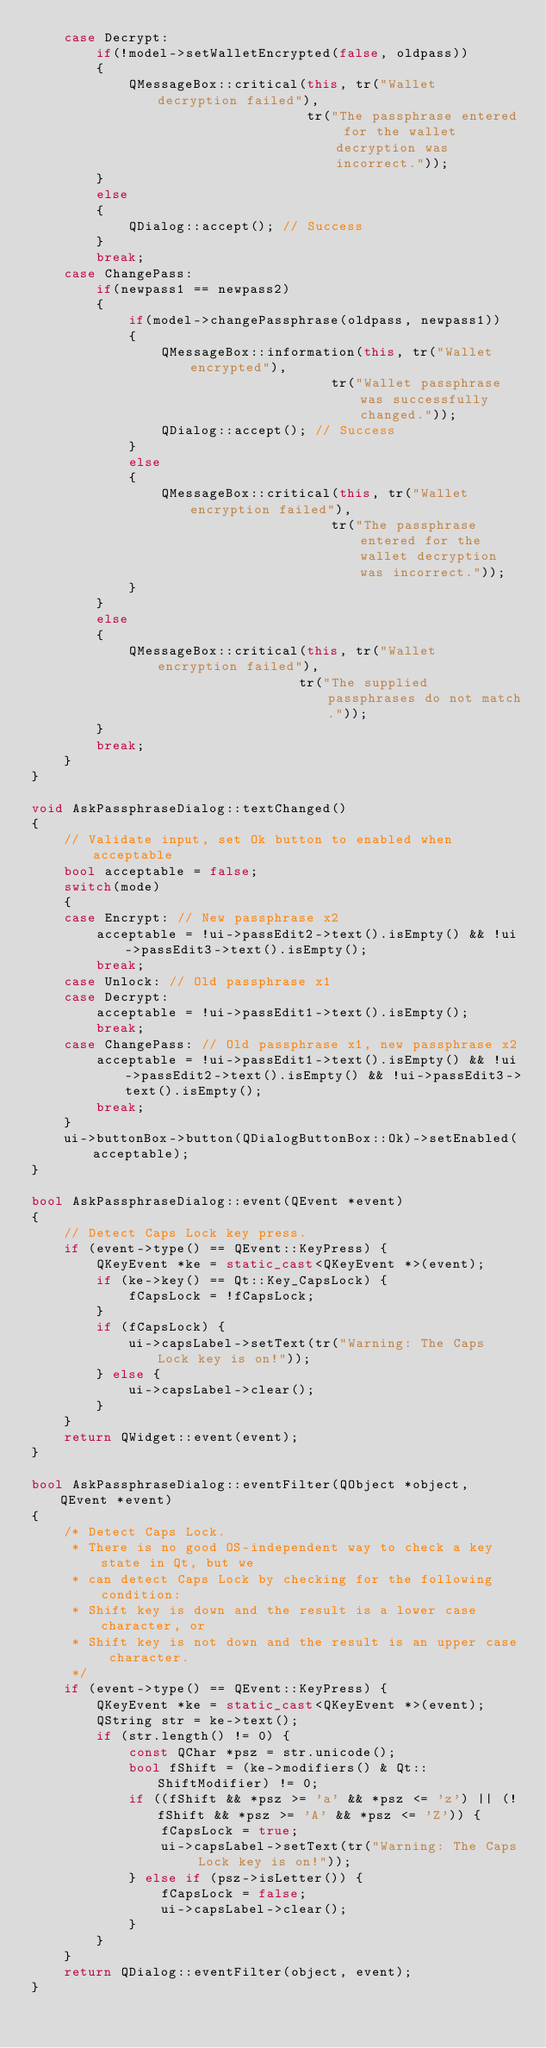<code> <loc_0><loc_0><loc_500><loc_500><_C++_>    case Decrypt:
        if(!model->setWalletEncrypted(false, oldpass))
        {
            QMessageBox::critical(this, tr("Wallet decryption failed"),
                                  tr("The passphrase entered for the wallet decryption was incorrect."));
        }
        else
        {
            QDialog::accept(); // Success
        }
        break;
    case ChangePass:
        if(newpass1 == newpass2)
        {
            if(model->changePassphrase(oldpass, newpass1))
            {
                QMessageBox::information(this, tr("Wallet encrypted"),
                                     tr("Wallet passphrase was successfully changed."));
                QDialog::accept(); // Success
            }
            else
            {
                QMessageBox::critical(this, tr("Wallet encryption failed"),
                                     tr("The passphrase entered for the wallet decryption was incorrect."));
            }
        }
        else
        {
            QMessageBox::critical(this, tr("Wallet encryption failed"),
                                 tr("The supplied passphrases do not match."));
        }
        break;
    }
}

void AskPassphraseDialog::textChanged()
{
    // Validate input, set Ok button to enabled when acceptable
    bool acceptable = false;
    switch(mode)
    {
    case Encrypt: // New passphrase x2
        acceptable = !ui->passEdit2->text().isEmpty() && !ui->passEdit3->text().isEmpty();
        break;
    case Unlock: // Old passphrase x1
    case Decrypt:
        acceptable = !ui->passEdit1->text().isEmpty();
        break;
    case ChangePass: // Old passphrase x1, new passphrase x2
        acceptable = !ui->passEdit1->text().isEmpty() && !ui->passEdit2->text().isEmpty() && !ui->passEdit3->text().isEmpty();
        break;
    }
    ui->buttonBox->button(QDialogButtonBox::Ok)->setEnabled(acceptable);
}

bool AskPassphraseDialog::event(QEvent *event)
{
    // Detect Caps Lock key press.
    if (event->type() == QEvent::KeyPress) {
        QKeyEvent *ke = static_cast<QKeyEvent *>(event);
        if (ke->key() == Qt::Key_CapsLock) {
            fCapsLock = !fCapsLock;
        }
        if (fCapsLock) {
            ui->capsLabel->setText(tr("Warning: The Caps Lock key is on!"));
        } else {
            ui->capsLabel->clear();
        }
    }
    return QWidget::event(event);
}

bool AskPassphraseDialog::eventFilter(QObject *object, QEvent *event)
{
    /* Detect Caps Lock.
     * There is no good OS-independent way to check a key state in Qt, but we
     * can detect Caps Lock by checking for the following condition:
     * Shift key is down and the result is a lower case character, or
     * Shift key is not down and the result is an upper case character.
     */
    if (event->type() == QEvent::KeyPress) {
        QKeyEvent *ke = static_cast<QKeyEvent *>(event);
        QString str = ke->text();
        if (str.length() != 0) {
            const QChar *psz = str.unicode();
            bool fShift = (ke->modifiers() & Qt::ShiftModifier) != 0;
            if ((fShift && *psz >= 'a' && *psz <= 'z') || (!fShift && *psz >= 'A' && *psz <= 'Z')) {
                fCapsLock = true;
                ui->capsLabel->setText(tr("Warning: The Caps Lock key is on!"));
            } else if (psz->isLetter()) {
                fCapsLock = false;
                ui->capsLabel->clear();
            }
        }
    }
    return QDialog::eventFilter(object, event);
}
</code> 